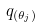<formula> <loc_0><loc_0><loc_500><loc_500>q _ { ( \theta _ { j } ) }</formula> 